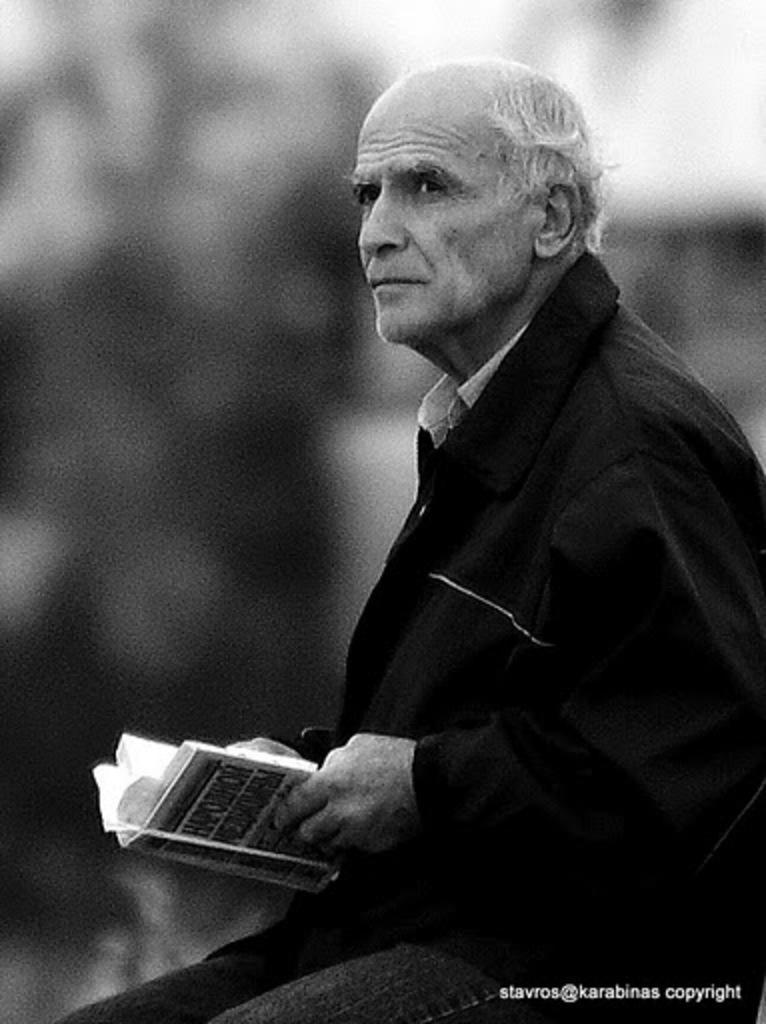Please provide a concise description of this image. In this picture we can see a person,he is holding a book and in the background we can see it is dark. 